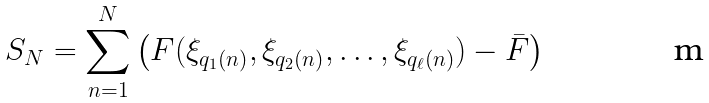<formula> <loc_0><loc_0><loc_500><loc_500>S _ { N } = \sum _ { n = 1 } ^ { N } \left ( F ( \xi _ { q _ { 1 } ( n ) } , \xi _ { q _ { 2 } ( n ) } , \dots , \xi _ { q _ { \ell } ( n ) } ) - \bar { F } \right )</formula> 